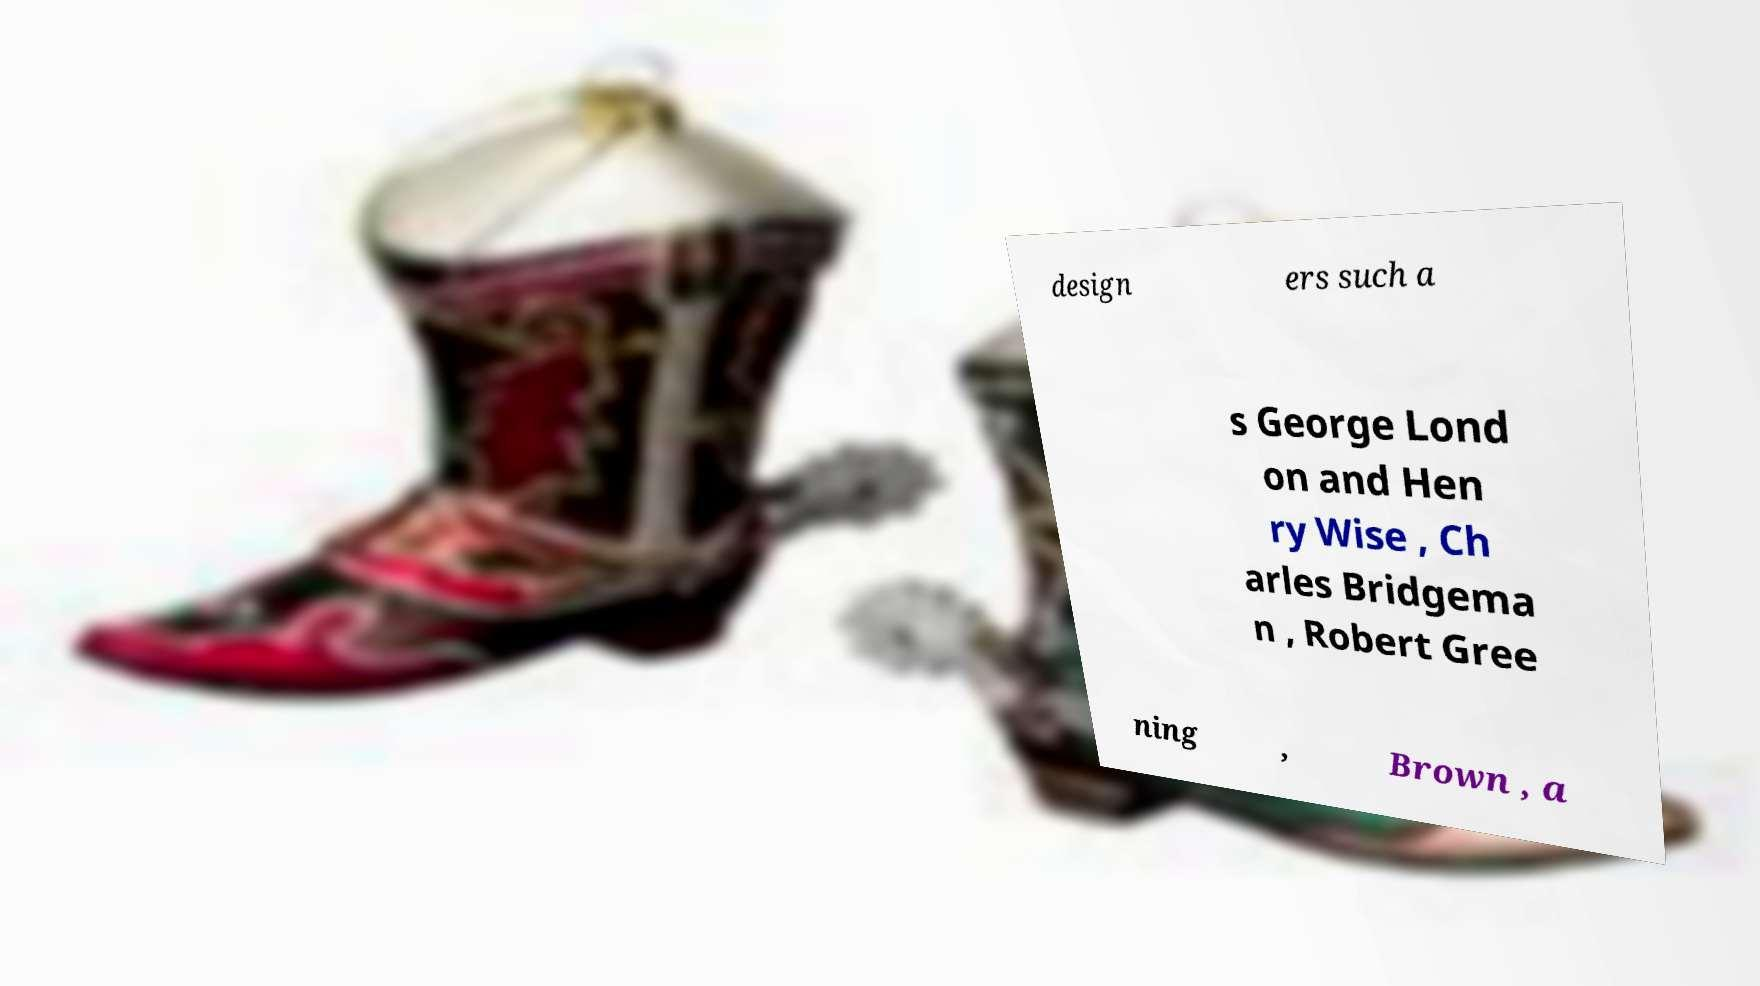For documentation purposes, I need the text within this image transcribed. Could you provide that? design ers such a s George Lond on and Hen ry Wise , Ch arles Bridgema n , Robert Gree ning , Brown , a 